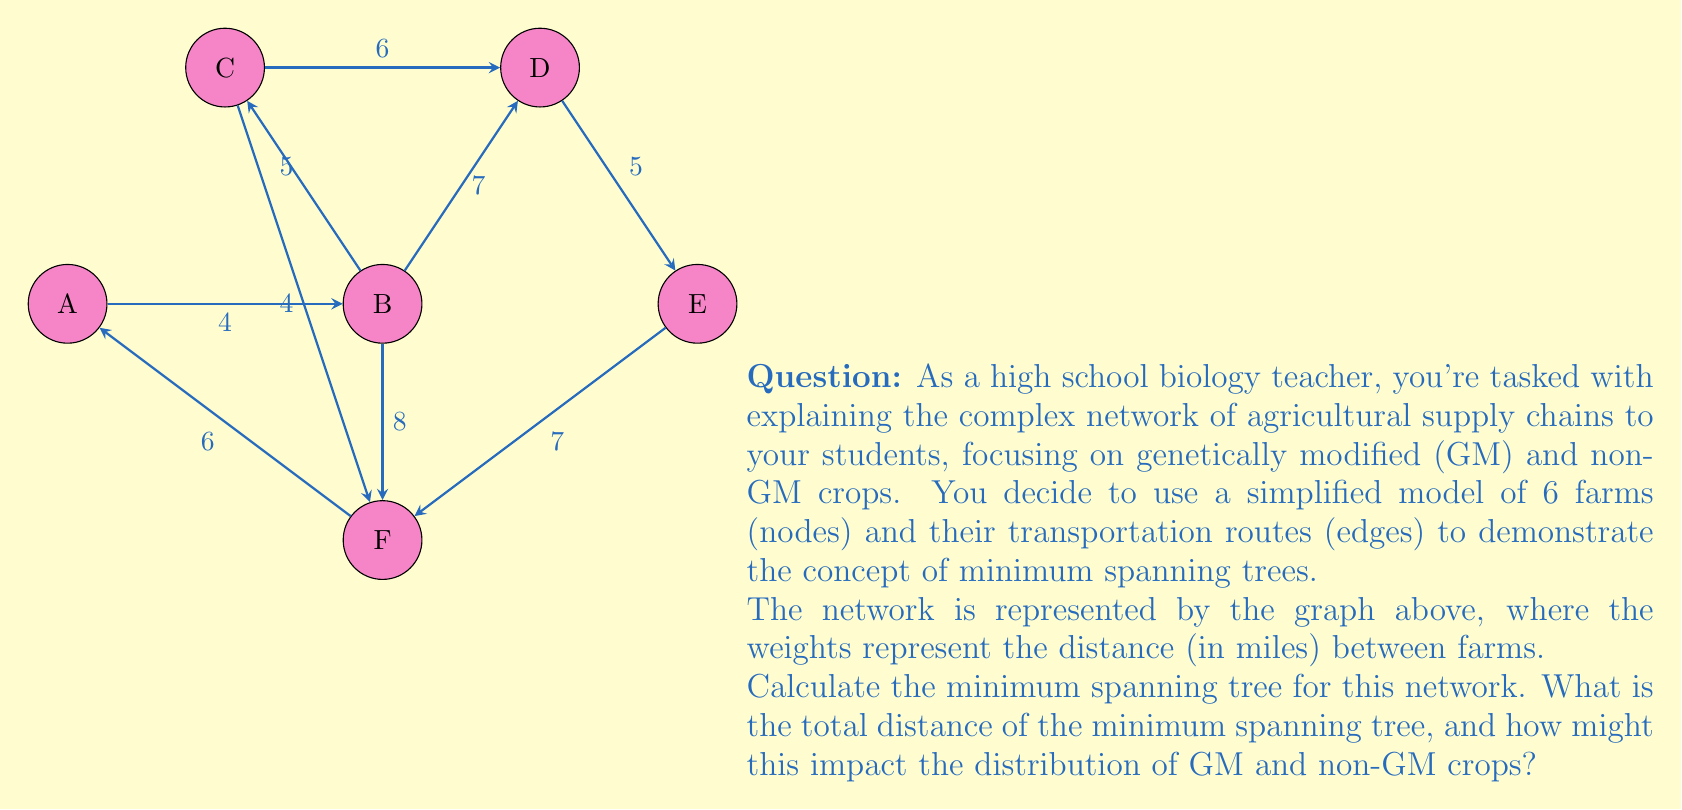Solve this math problem. To find the minimum spanning tree, we'll use Kruskal's algorithm:

1) Sort all edges by weight (distance):
   BC = 5, DE = 5, AB = 4, CF = 4, CD = 6, AF = 6, BD = 7, EF = 7, BF = 8

2) Start with an empty graph and add edges in order, skipping those that would create a cycle:

   - Add BC (5)
   - Add DE (5)
   - Add AB (4)
   - Add CF (4)
   - Add CD (6)

3) At this point, we have 5 edges connecting all 6 nodes, so we stop.

4) The minimum spanning tree consists of edges: BC, DE, AB, CF, CD

5) Calculate total distance: 5 + 5 + 4 + 4 + 6 = 24 miles

Impact on GM and non-GM crop distribution:
The minimum spanning tree represents the most efficient way to connect all farms with the shortest total distance. This could minimize transportation costs and reduce the risk of cross-contamination between GM and non-GM crops. However, it may also limit the isolation of GM crops, potentially leading to debates about the coexistence of different agricultural practices.
Answer: 24 miles 